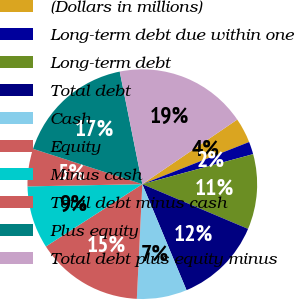Convert chart to OTSL. <chart><loc_0><loc_0><loc_500><loc_500><pie_chart><fcel>(Dollars in millions)<fcel>Long-term debt due within one<fcel>Long-term debt<fcel>Total debt<fcel>Cash<fcel>Equity<fcel>Minus cash<fcel>Total debt minus cash<fcel>Plus equity<fcel>Total debt plus equity minus<nl><fcel>3.53%<fcel>1.77%<fcel>10.58%<fcel>12.34%<fcel>7.05%<fcel>15.11%<fcel>8.82%<fcel>5.29%<fcel>16.87%<fcel>18.64%<nl></chart> 